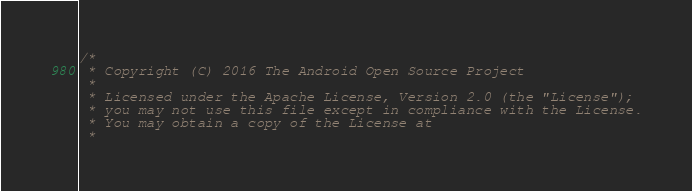Convert code to text. <code><loc_0><loc_0><loc_500><loc_500><_C_>/*
 * Copyright (C) 2016 The Android Open Source Project
 *
 * Licensed under the Apache License, Version 2.0 (the "License");
 * you may not use this file except in compliance with the License.
 * You may obtain a copy of the License at
 *</code> 